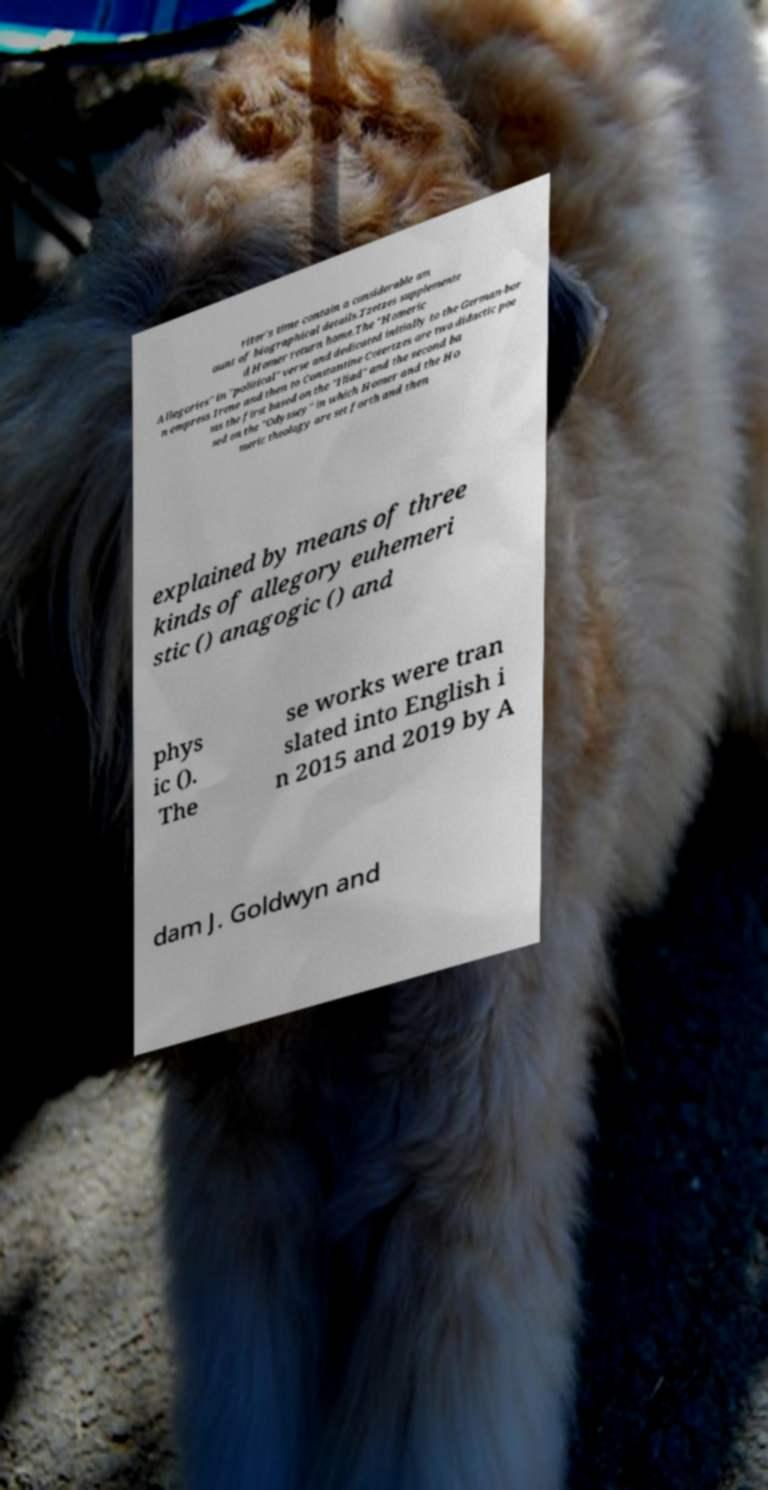Please read and relay the text visible in this image. What does it say? riter's time contain a considerable am ount of biographical details.Tzetzes supplemente d Homer return home.The "Homeric Allegories" in "political" verse and dedicated initially to the German-bor n empress Irene and then to Constantine Cotertzes are two didactic poe ms the first based on the "Iliad" and the second ba sed on the "Odyssey" in which Homer and the Ho meric theology are set forth and then explained by means of three kinds of allegory euhemeri stic () anagogic () and phys ic (). The se works were tran slated into English i n 2015 and 2019 by A dam J. Goldwyn and 